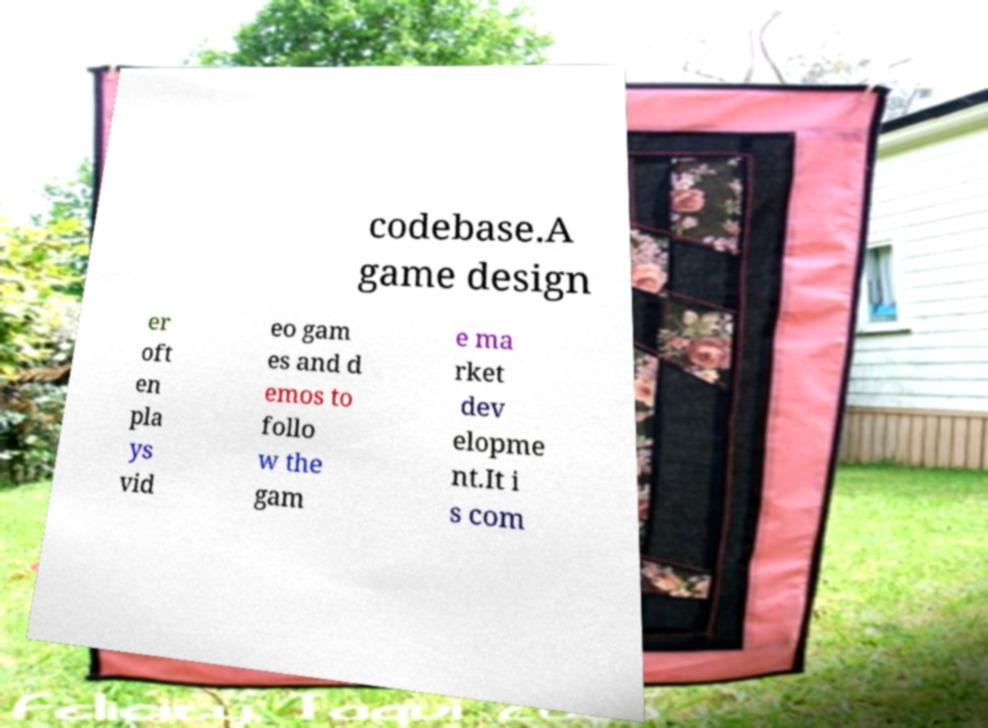Can you read and provide the text displayed in the image?This photo seems to have some interesting text. Can you extract and type it out for me? codebase.A game design er oft en pla ys vid eo gam es and d emos to follo w the gam e ma rket dev elopme nt.It i s com 